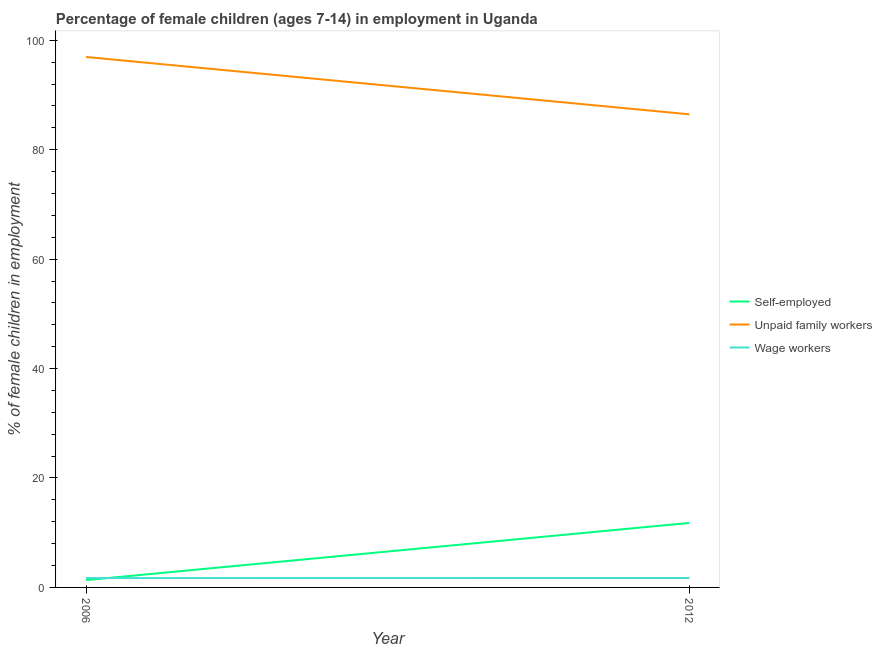How many different coloured lines are there?
Your answer should be very brief. 3. Does the line corresponding to percentage of children employed as unpaid family workers intersect with the line corresponding to percentage of self employed children?
Make the answer very short. No. What is the percentage of children employed as unpaid family workers in 2006?
Your answer should be very brief. 96.95. Across all years, what is the maximum percentage of self employed children?
Provide a succinct answer. 11.79. Across all years, what is the minimum percentage of children employed as wage workers?
Give a very brief answer. 1.71. In which year was the percentage of self employed children maximum?
Your response must be concise. 2012. In which year was the percentage of children employed as unpaid family workers minimum?
Provide a succinct answer. 2012. What is the total percentage of self employed children in the graph?
Your answer should be compact. 13.13. What is the difference between the percentage of children employed as unpaid family workers in 2006 and that in 2012?
Your answer should be compact. 10.48. What is the difference between the percentage of children employed as unpaid family workers in 2012 and the percentage of children employed as wage workers in 2006?
Give a very brief answer. 84.76. What is the average percentage of children employed as unpaid family workers per year?
Provide a short and direct response. 91.71. In the year 2012, what is the difference between the percentage of children employed as wage workers and percentage of children employed as unpaid family workers?
Your answer should be very brief. -84.75. In how many years, is the percentage of children employed as wage workers greater than 72 %?
Your answer should be compact. 0. What is the ratio of the percentage of self employed children in 2006 to that in 2012?
Your response must be concise. 0.11. In how many years, is the percentage of children employed as unpaid family workers greater than the average percentage of children employed as unpaid family workers taken over all years?
Your answer should be very brief. 1. Is it the case that in every year, the sum of the percentage of self employed children and percentage of children employed as unpaid family workers is greater than the percentage of children employed as wage workers?
Your answer should be very brief. Yes. Does the percentage of children employed as unpaid family workers monotonically increase over the years?
Offer a terse response. No. Is the percentage of self employed children strictly greater than the percentage of children employed as unpaid family workers over the years?
Your answer should be very brief. No. How many years are there in the graph?
Provide a short and direct response. 2. Where does the legend appear in the graph?
Offer a very short reply. Center right. What is the title of the graph?
Make the answer very short. Percentage of female children (ages 7-14) in employment in Uganda. What is the label or title of the X-axis?
Ensure brevity in your answer.  Year. What is the label or title of the Y-axis?
Your answer should be very brief. % of female children in employment. What is the % of female children in employment of Self-employed in 2006?
Offer a very short reply. 1.34. What is the % of female children in employment in Unpaid family workers in 2006?
Offer a terse response. 96.95. What is the % of female children in employment of Wage workers in 2006?
Your answer should be compact. 1.71. What is the % of female children in employment in Self-employed in 2012?
Offer a very short reply. 11.79. What is the % of female children in employment of Unpaid family workers in 2012?
Keep it short and to the point. 86.47. What is the % of female children in employment in Wage workers in 2012?
Provide a succinct answer. 1.72. Across all years, what is the maximum % of female children in employment in Self-employed?
Make the answer very short. 11.79. Across all years, what is the maximum % of female children in employment in Unpaid family workers?
Provide a short and direct response. 96.95. Across all years, what is the maximum % of female children in employment in Wage workers?
Make the answer very short. 1.72. Across all years, what is the minimum % of female children in employment in Self-employed?
Offer a very short reply. 1.34. Across all years, what is the minimum % of female children in employment in Unpaid family workers?
Your answer should be very brief. 86.47. Across all years, what is the minimum % of female children in employment in Wage workers?
Ensure brevity in your answer.  1.71. What is the total % of female children in employment of Self-employed in the graph?
Your answer should be compact. 13.13. What is the total % of female children in employment in Unpaid family workers in the graph?
Make the answer very short. 183.42. What is the total % of female children in employment in Wage workers in the graph?
Offer a terse response. 3.43. What is the difference between the % of female children in employment of Self-employed in 2006 and that in 2012?
Offer a very short reply. -10.45. What is the difference between the % of female children in employment of Unpaid family workers in 2006 and that in 2012?
Make the answer very short. 10.48. What is the difference between the % of female children in employment of Wage workers in 2006 and that in 2012?
Provide a succinct answer. -0.01. What is the difference between the % of female children in employment in Self-employed in 2006 and the % of female children in employment in Unpaid family workers in 2012?
Your answer should be very brief. -85.13. What is the difference between the % of female children in employment in Self-employed in 2006 and the % of female children in employment in Wage workers in 2012?
Your response must be concise. -0.38. What is the difference between the % of female children in employment of Unpaid family workers in 2006 and the % of female children in employment of Wage workers in 2012?
Provide a succinct answer. 95.23. What is the average % of female children in employment in Self-employed per year?
Keep it short and to the point. 6.57. What is the average % of female children in employment in Unpaid family workers per year?
Offer a very short reply. 91.71. What is the average % of female children in employment of Wage workers per year?
Your answer should be very brief. 1.72. In the year 2006, what is the difference between the % of female children in employment in Self-employed and % of female children in employment in Unpaid family workers?
Offer a terse response. -95.61. In the year 2006, what is the difference between the % of female children in employment of Self-employed and % of female children in employment of Wage workers?
Make the answer very short. -0.37. In the year 2006, what is the difference between the % of female children in employment of Unpaid family workers and % of female children in employment of Wage workers?
Make the answer very short. 95.24. In the year 2012, what is the difference between the % of female children in employment of Self-employed and % of female children in employment of Unpaid family workers?
Keep it short and to the point. -74.68. In the year 2012, what is the difference between the % of female children in employment of Self-employed and % of female children in employment of Wage workers?
Keep it short and to the point. 10.07. In the year 2012, what is the difference between the % of female children in employment of Unpaid family workers and % of female children in employment of Wage workers?
Give a very brief answer. 84.75. What is the ratio of the % of female children in employment in Self-employed in 2006 to that in 2012?
Your response must be concise. 0.11. What is the ratio of the % of female children in employment of Unpaid family workers in 2006 to that in 2012?
Make the answer very short. 1.12. What is the difference between the highest and the second highest % of female children in employment of Self-employed?
Keep it short and to the point. 10.45. What is the difference between the highest and the second highest % of female children in employment in Unpaid family workers?
Make the answer very short. 10.48. What is the difference between the highest and the lowest % of female children in employment in Self-employed?
Provide a succinct answer. 10.45. What is the difference between the highest and the lowest % of female children in employment in Unpaid family workers?
Keep it short and to the point. 10.48. 